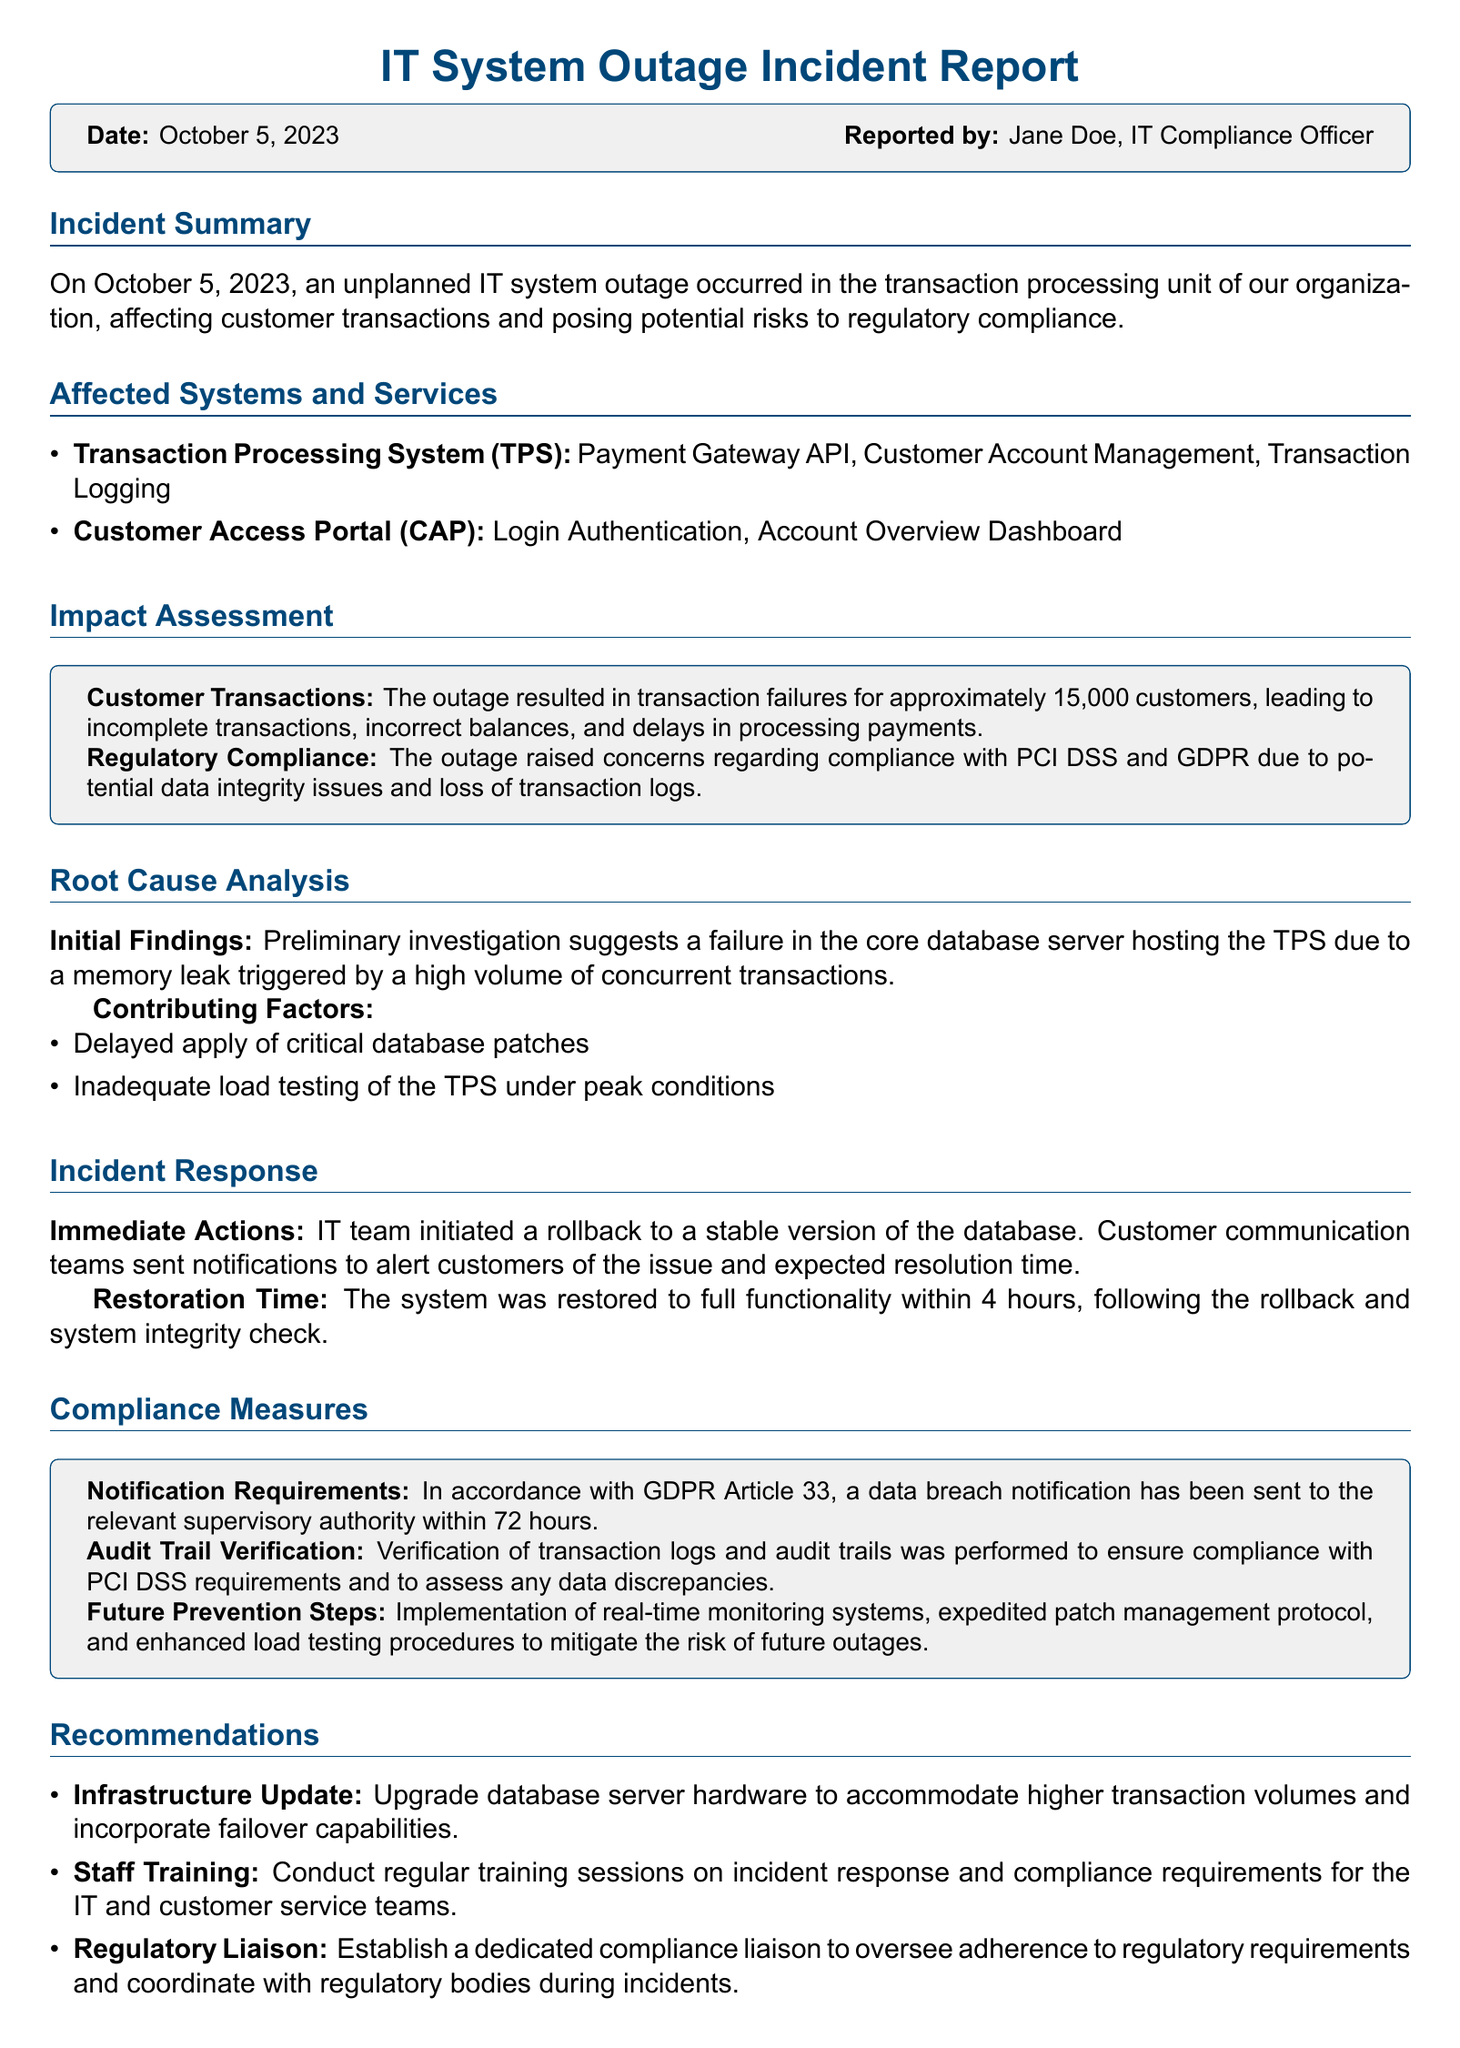What was the date of the incident? The date of the incident is mentioned at the beginning of the report.
Answer: October 5, 2023 Who reported the incident? The name of the person who reported the incident is given in the infobox.
Answer: Jane Doe, IT Compliance Officer How many customers were affected by the outage? The number of customers affected is specified in the impact assessment section.
Answer: Approximately 15,000 customers What was one immediate action taken during the incident response? The document lists immediate actions taken by the IT team after the outage.
Answer: Rollback to a stable version of the database What compliance measures were taken regarding GDPR? The compliance measures section specifies the actions taken according to GDPR.
Answer: Data breach notification sent What was one contributing factor to the outage? The root cause analysis lists factors that contributed to the outage.
Answer: Delayed apply of critical database patches What is one recommendation for future prevention? The recommendations section provides suggestions for avoiding similar issues in the future.
Answer: Upgrade database server hardware What was the restoration time for the system? The restoration time is mentioned in the incident response section of the document.
Answer: 4 hours 